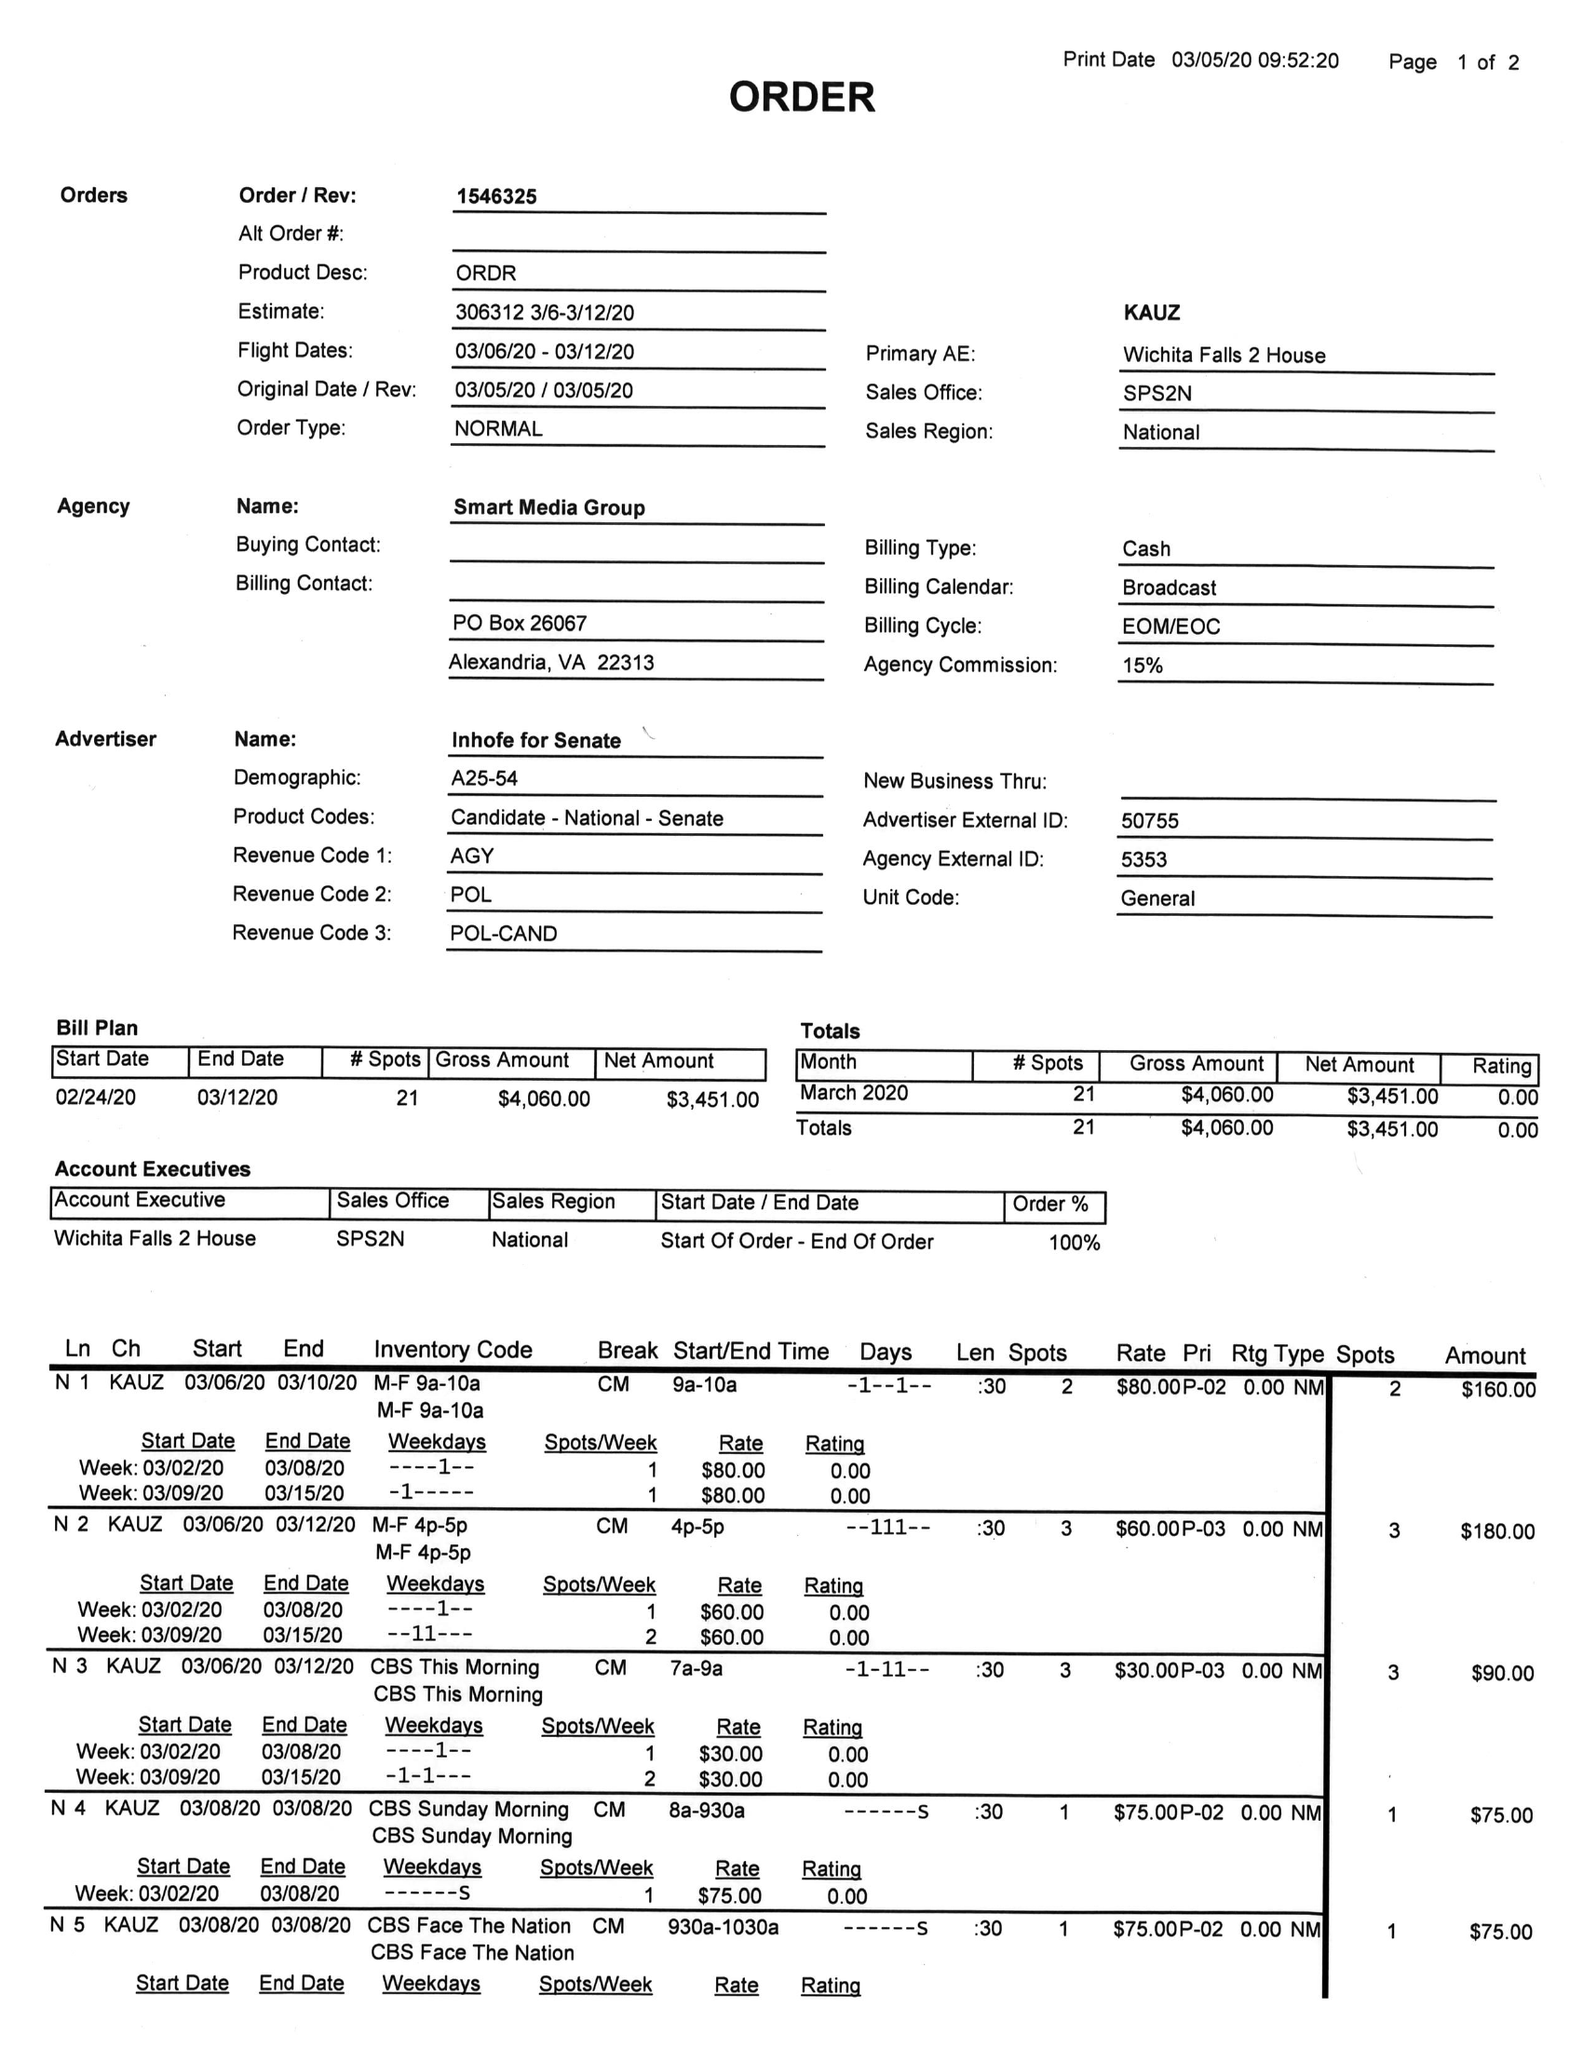What is the value for the flight_from?
Answer the question using a single word or phrase. 03/06/20 